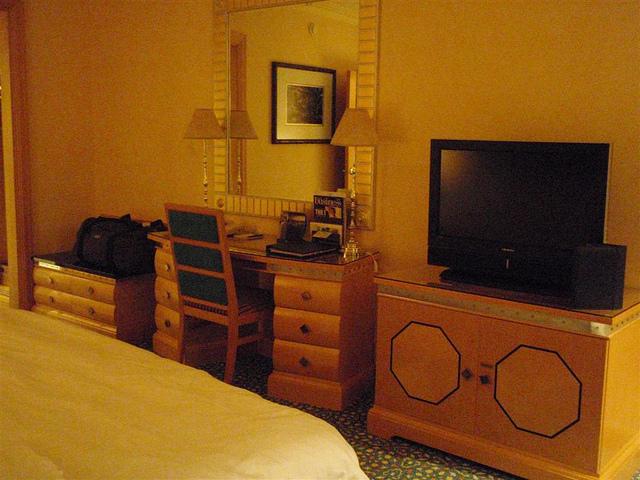What street sign is shaped like the design on the television cabinet doors?
Quick response, please. Stop sign. Where is the television?
Keep it brief. Dresser. Is there an area rug in the room?
Short answer required. No. What color are the storage doors?
Keep it brief. Brown. 